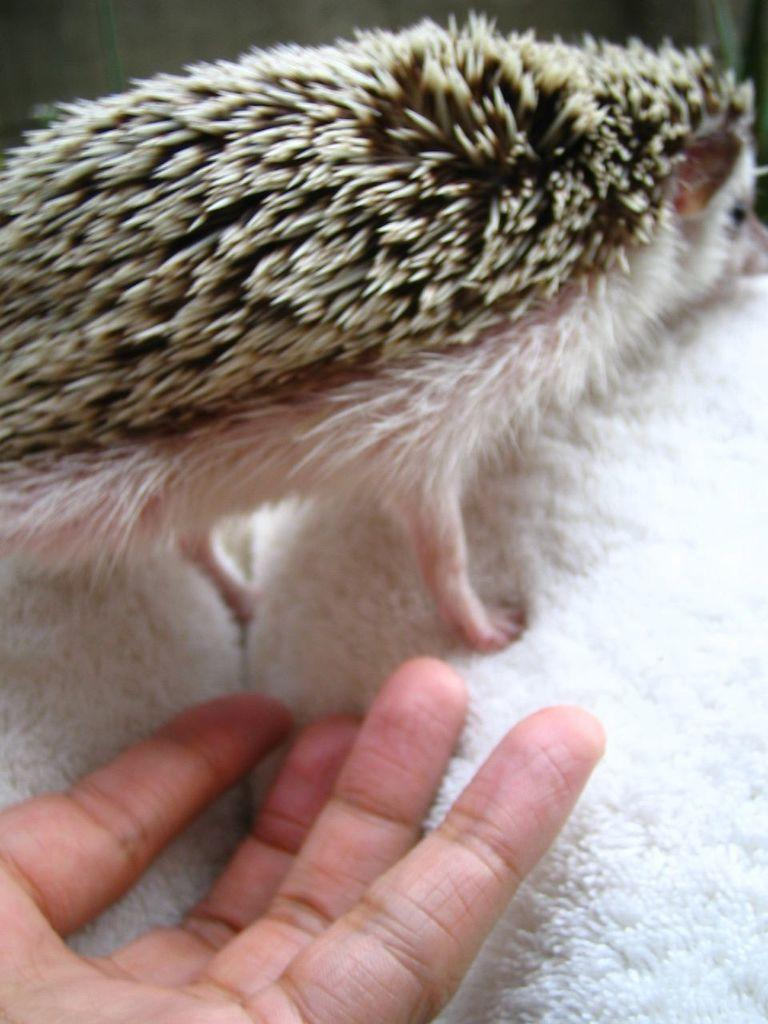What type of animal is in the image? There is an animal in the image, but its specific type cannot be determined from the provided facts. What colors can be seen on the animal? The animal has brown, cream, and white colors. What is the animal resting on? The animal is on a white cloth. Is there any human presence in the image? Yes, a person's hand is on the white cloth. How many apples are being ironed by the person in the image? There are no apples or ironing activity present in the image. What type of bean is visible on the animal's fur in the image? There is no bean present on the animal's fur in the image. 